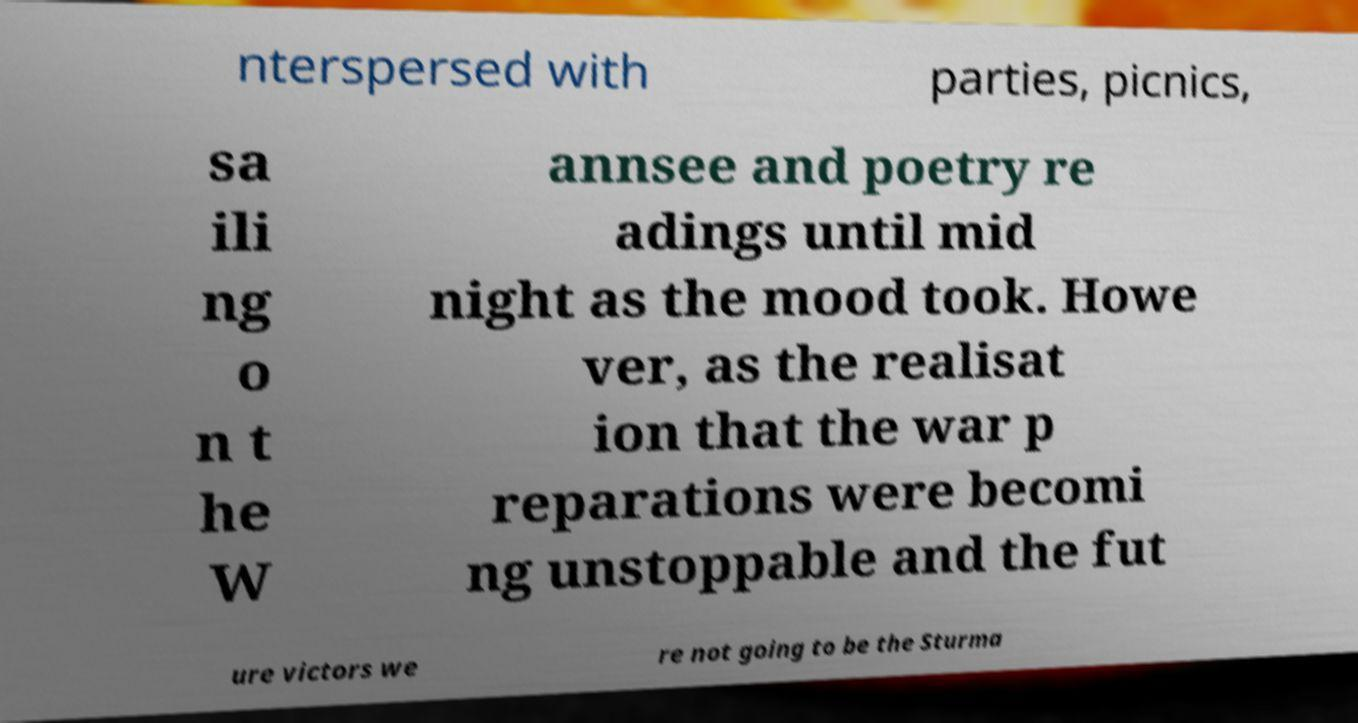Can you accurately transcribe the text from the provided image for me? nterspersed with parties, picnics, sa ili ng o n t he W annsee and poetry re adings until mid night as the mood took. Howe ver, as the realisat ion that the war p reparations were becomi ng unstoppable and the fut ure victors we re not going to be the Sturma 